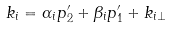<formula> <loc_0><loc_0><loc_500><loc_500>k _ { i } = \alpha _ { i } p ^ { \prime } _ { 2 } + \beta _ { i } p ^ { \prime } _ { 1 } + k _ { i \perp }</formula> 